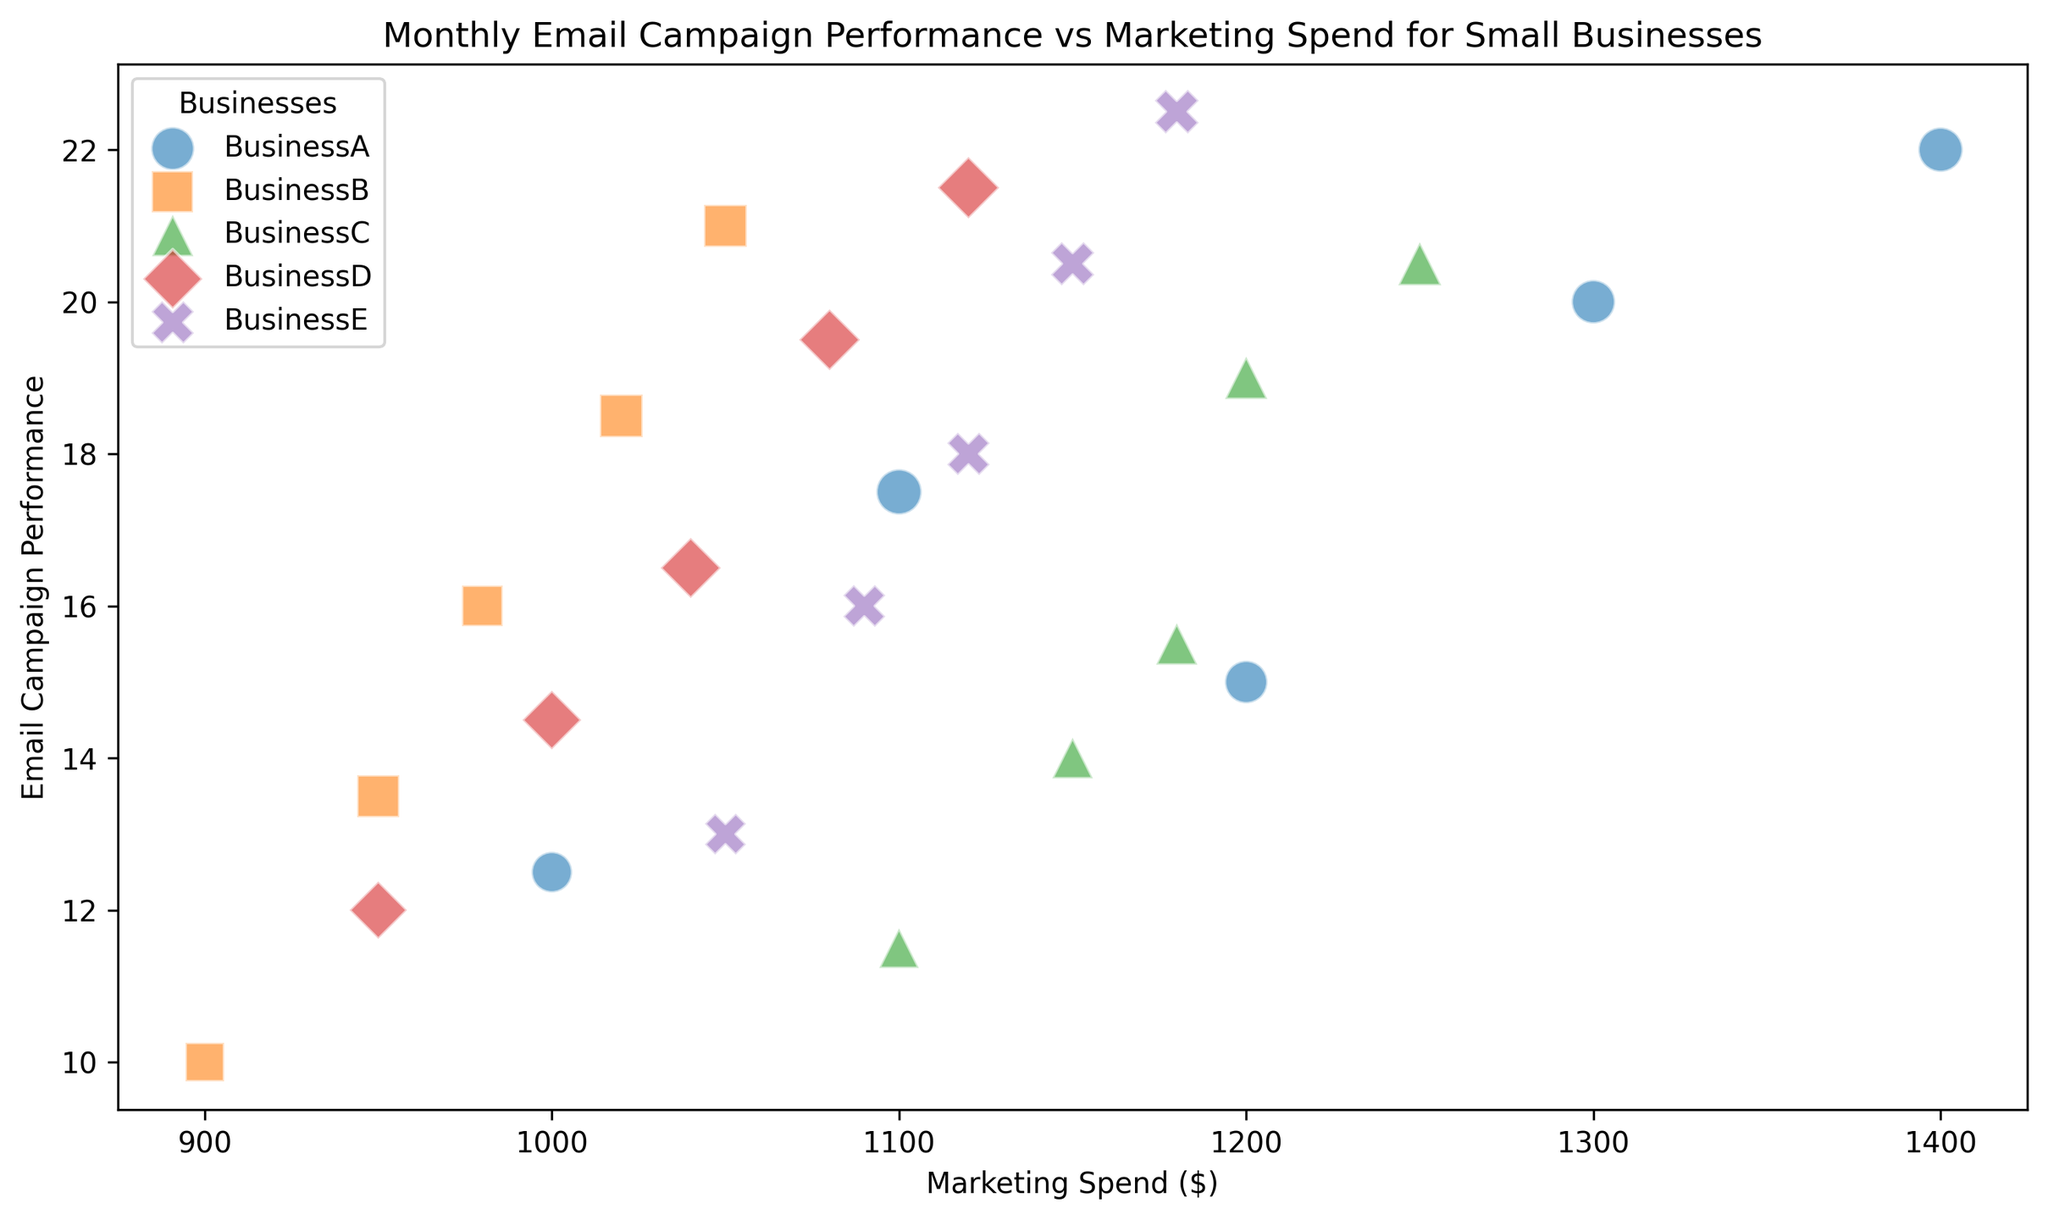Which business has the highest email campaign performance in May? To find this, look at the data points corresponding to the month of May across all businesses and identify the highest value on the y-axis. BusinessE reaches 22.5 in May.
Answer: BusinessE Which business had the highest marketing spend in April? Look at the x-axis for points corresponding to April and find the business with the maximum x-axis value. BusinessA spent $1300 in April.
Answer: BusinessA What is the difference in email campaign performance between BusinessA and BusinessB in March? Identify the y-axis positions for BusinessA and BusinessB in March and subtract the smaller value from the larger one: 17.5 (BusinessA) - 16.0 (BusinessB) = 1.5.
Answer: 1.5 Which business had the smallest bubble in March? Find the smallest bubble that appears on the plot in March (size indicating number of emails). Based on the dataset, BusinessB had the smallest bubble with 205 emails.
Answer: BusinessB What is the average marketing spend of all businesses in February? Sum the marketing spends for all businesses in February and divide by the number of businesses: (1200 + 950 + 1150 + 1000 + 1090) / 5 = 4825 / 5 = 965
Answer: 965 What is the total number of emails sent by BusinessC across all months? Sum the 'NumberOfEmails' values for BusinessC: 190 + 200 + 207 + 217 + 225 = 1039
Answer: 1039 Is there a correlation between marketing spend and email campaign performance across all businesses? Visually inspect if as marketing spend increases, email campaign performance tends to increase too. The scatter plot shows an upward trend, indicating a positive correlation.
Answer: Yes Which business has the most consistent email campaign performance over the months? Look at the vertical spread of the plots for each business. BusinessA shows a consistent increase and relatively stable performance around 12.5 to 22.0.
Answer: BusinessA What color and shape represents BusinessD on the plot? Refer to the legend in the plot. BusinessD is represented by the color red and a diamond shape.
Answer: Red, Diamond 